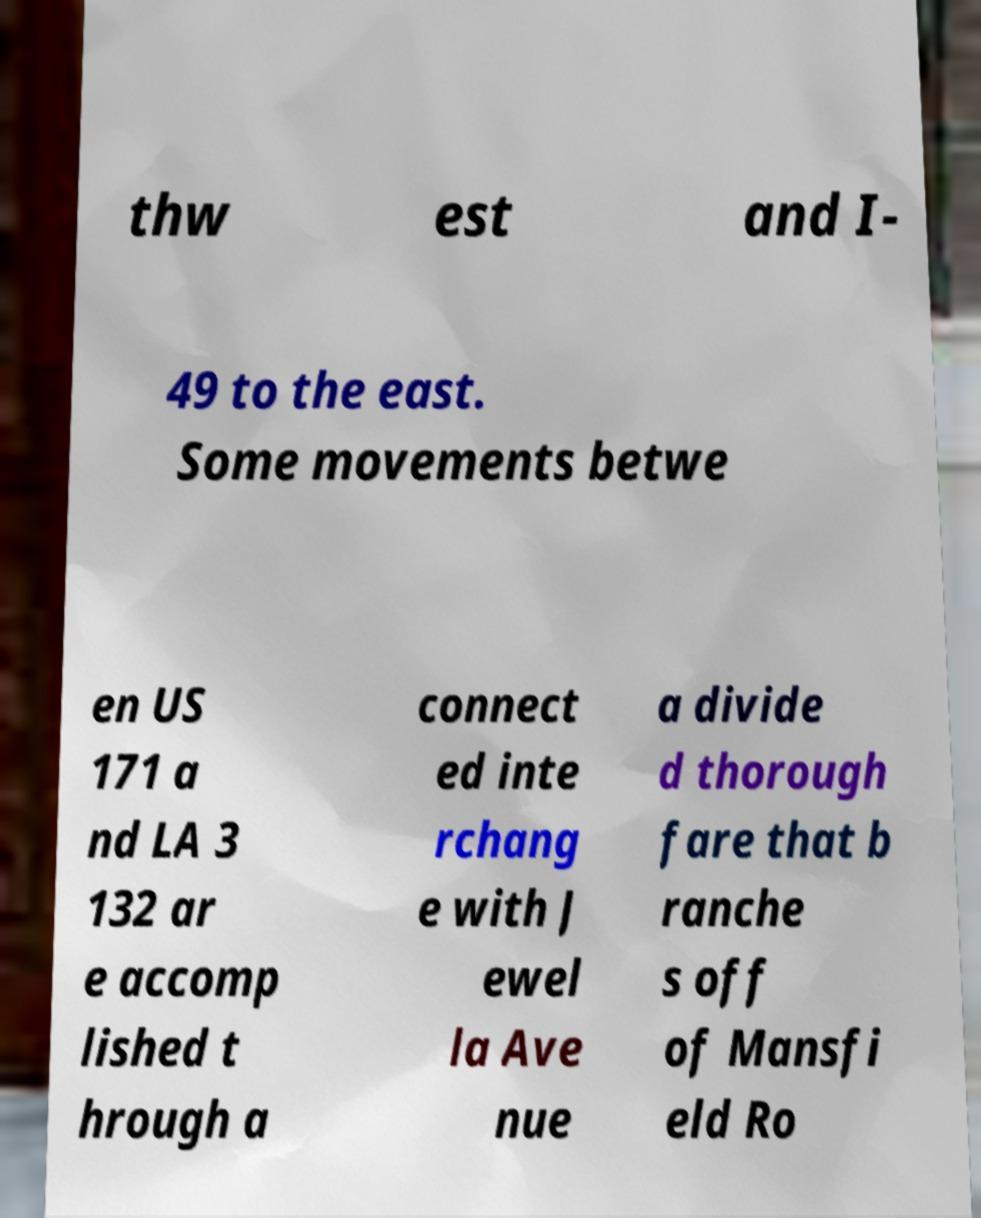Please read and relay the text visible in this image. What does it say? thw est and I- 49 to the east. Some movements betwe en US 171 a nd LA 3 132 ar e accomp lished t hrough a connect ed inte rchang e with J ewel la Ave nue a divide d thorough fare that b ranche s off of Mansfi eld Ro 